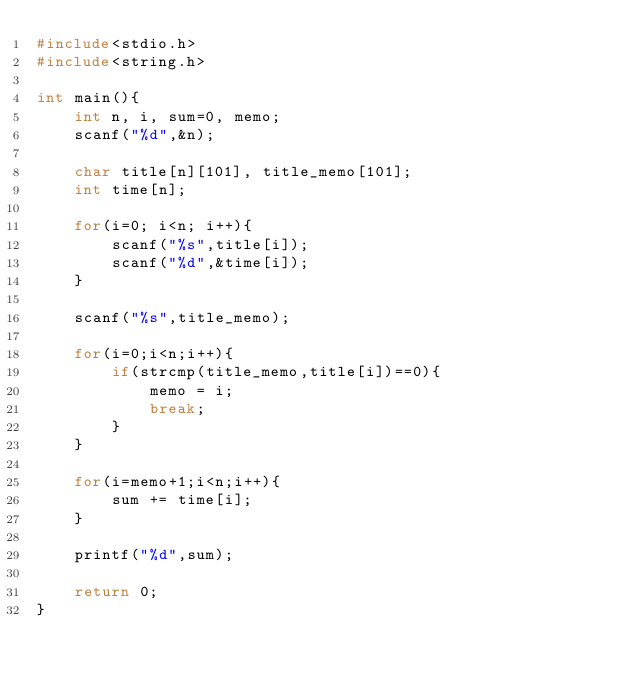<code> <loc_0><loc_0><loc_500><loc_500><_C_>#include<stdio.h>
#include<string.h>

int main(){
    int n, i, sum=0, memo;
    scanf("%d",&n);

    char title[n][101], title_memo[101];
    int time[n];

    for(i=0; i<n; i++){
        scanf("%s",title[i]);
        scanf("%d",&time[i]);
    }

    scanf("%s",title_memo);

    for(i=0;i<n;i++){
        if(strcmp(title_memo,title[i])==0){
            memo = i;
            break;
        }
    }

    for(i=memo+1;i<n;i++){
        sum += time[i];
    }

    printf("%d",sum);

    return 0;
}</code> 